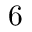Convert formula to latex. <formula><loc_0><loc_0><loc_500><loc_500>6</formula> 